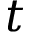Convert formula to latex. <formula><loc_0><loc_0><loc_500><loc_500>t</formula> 